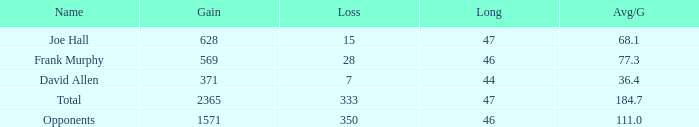Which Avg/G has a Name of david allen, and a Gain larger than 371? None. 